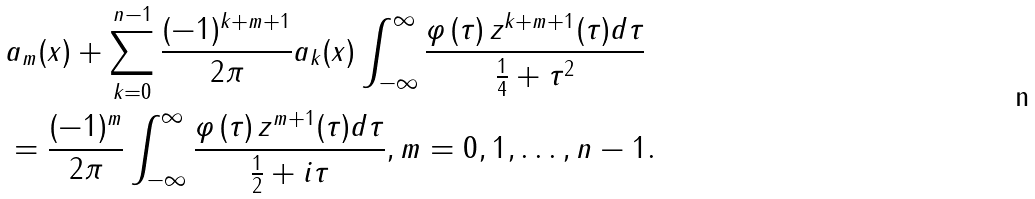<formula> <loc_0><loc_0><loc_500><loc_500>& a _ { m } ( x ) + \sum _ { k = 0 } ^ { n - 1 } \frac { ( - 1 ) ^ { k + m + 1 } } { 2 \pi } a _ { k } ( x ) \int _ { - \infty } ^ { \infty } \frac { \varphi \left ( \tau \right ) z ^ { k + m + 1 } ( \tau ) d \tau } { \frac { 1 } { 4 } + \tau ^ { 2 } } \\ & = \frac { ( - 1 ) ^ { m } } { 2 \pi } \int _ { - \infty } ^ { \infty } \frac { \varphi \left ( \tau \right ) z ^ { m + 1 } ( \tau ) d \tau } { \frac { 1 } { 2 } + i \tau } , m = 0 , 1 , \dots , n - 1 .</formula> 